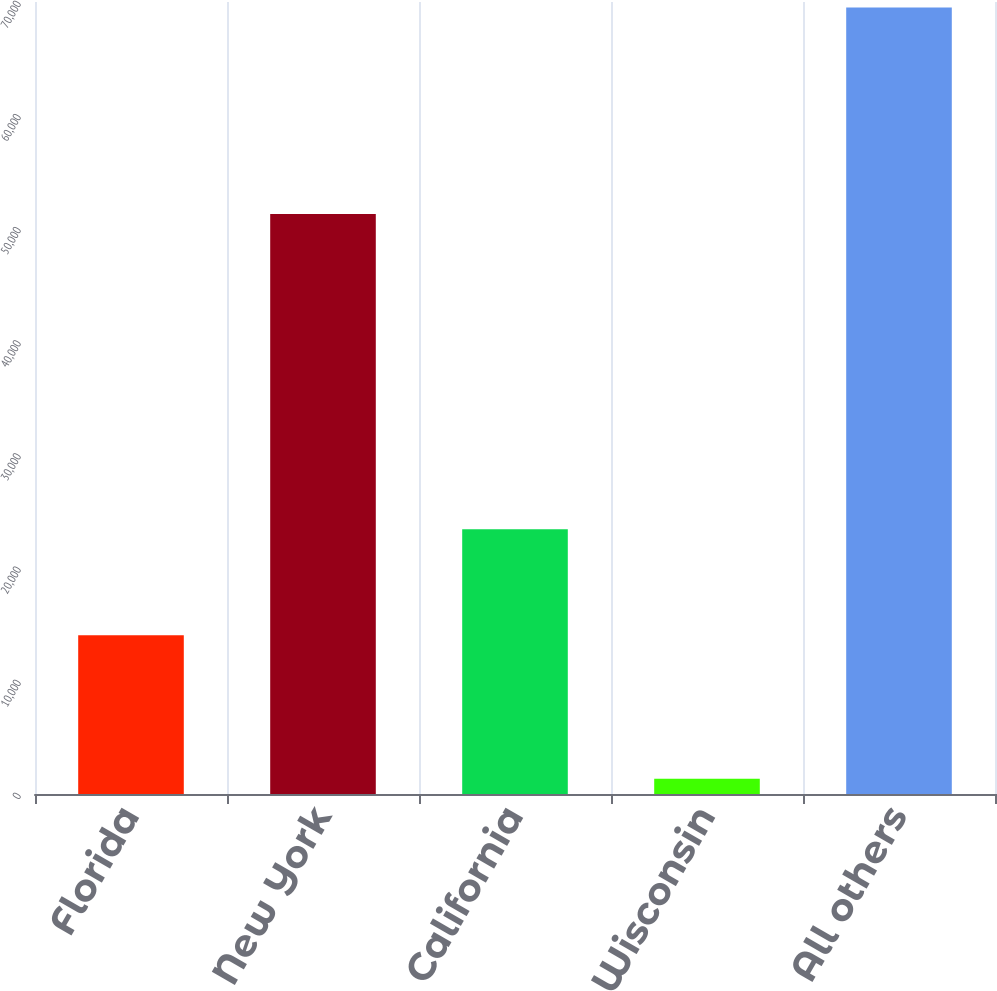Convert chart. <chart><loc_0><loc_0><loc_500><loc_500><bar_chart><fcel>Florida<fcel>New York<fcel>California<fcel>Wisconsin<fcel>All others<nl><fcel>14040<fcel>51264<fcel>23397<fcel>1358<fcel>69507<nl></chart> 